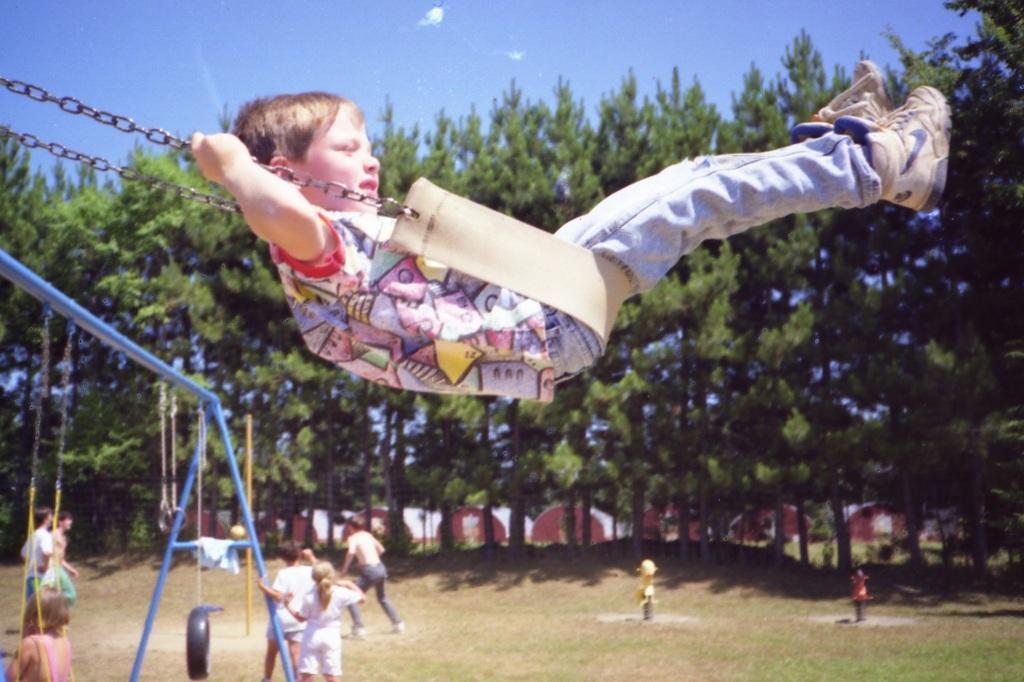How would you summarize this image in a sentence or two? In this image we can see a boy on a swing. On the backside we can see a group of people on the ground, some poles, rides, grass and a tire tied to a rope. We can also see some houses, a group of trees and the sky. 